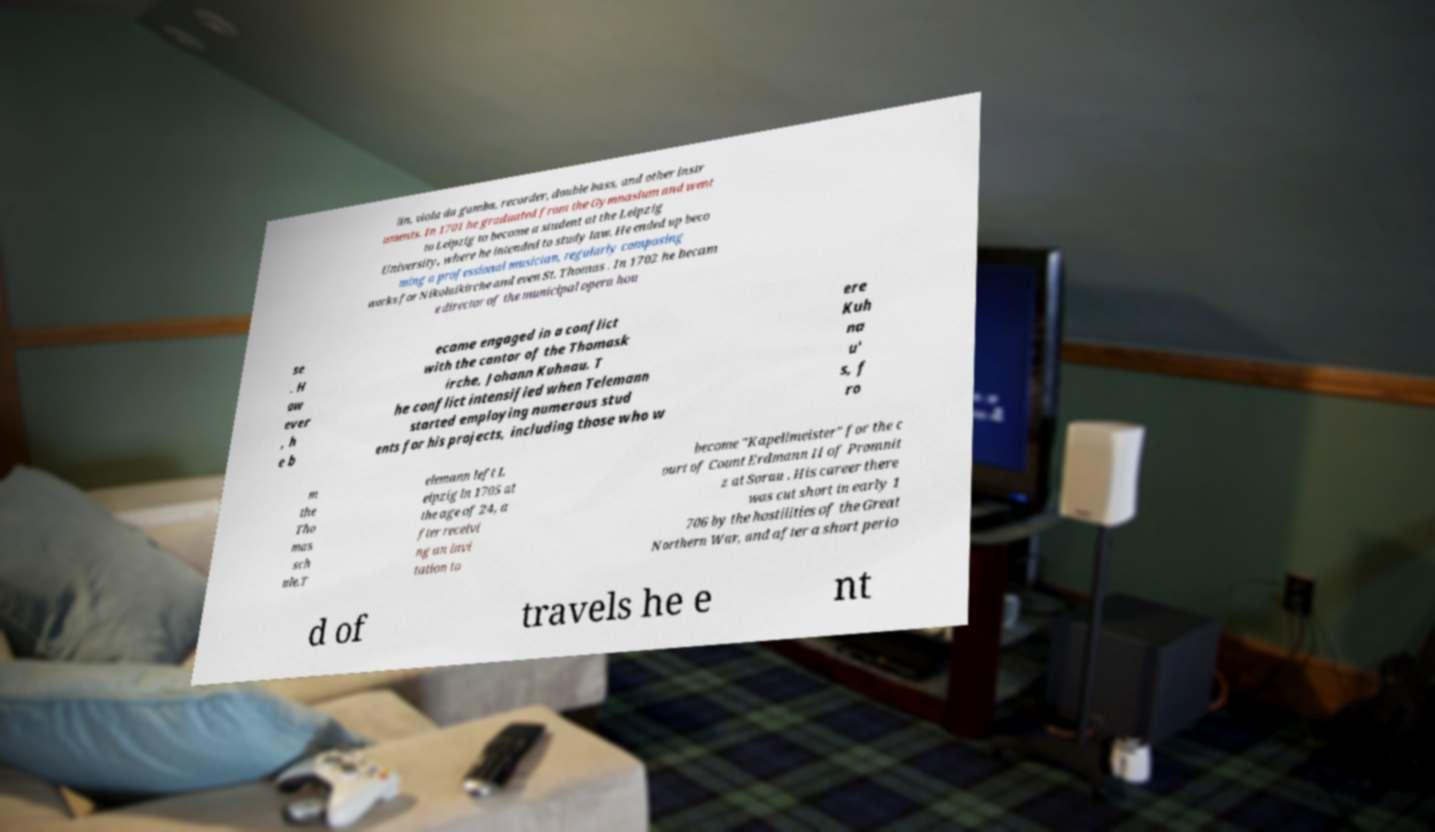I need the written content from this picture converted into text. Can you do that? lin, viola da gamba, recorder, double bass, and other instr uments. In 1701 he graduated from the Gymnasium and went to Leipzig to become a student at the Leipzig University, where he intended to study law. He ended up beco ming a professional musician, regularly composing works for Nikolaikirche and even St. Thomas . In 1702 he becam e director of the municipal opera hou se . H ow ever , h e b ecame engaged in a conflict with the cantor of the Thomask irche, Johann Kuhnau. T he conflict intensified when Telemann started employing numerous stud ents for his projects, including those who w ere Kuh na u' s, f ro m the Tho mas sch ule.T elemann left L eipzig in 1705 at the age of 24, a fter receivi ng an invi tation to become "Kapellmeister" for the c ourt of Count Erdmann II of Promnit z at Sorau . His career there was cut short in early 1 706 by the hostilities of the Great Northern War, and after a short perio d of travels he e nt 